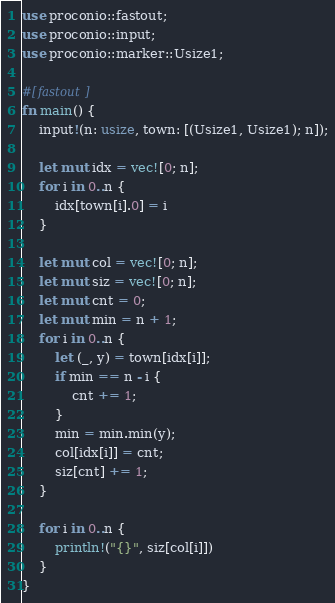<code> <loc_0><loc_0><loc_500><loc_500><_Rust_>use proconio::fastout;
use proconio::input;
use proconio::marker::Usize1;

#[fastout]
fn main() {
    input!(n: usize, town: [(Usize1, Usize1); n]);

    let mut idx = vec![0; n];
    for i in 0..n {
        idx[town[i].0] = i
    }

    let mut col = vec![0; n];
    let mut siz = vec![0; n];
    let mut cnt = 0;
    let mut min = n + 1;
    for i in 0..n {
        let (_, y) = town[idx[i]];
        if min == n - i {
            cnt += 1;
        }
        min = min.min(y);
        col[idx[i]] = cnt;
        siz[cnt] += 1;
    }

    for i in 0..n {
        println!("{}", siz[col[i]])
    }
}
</code> 